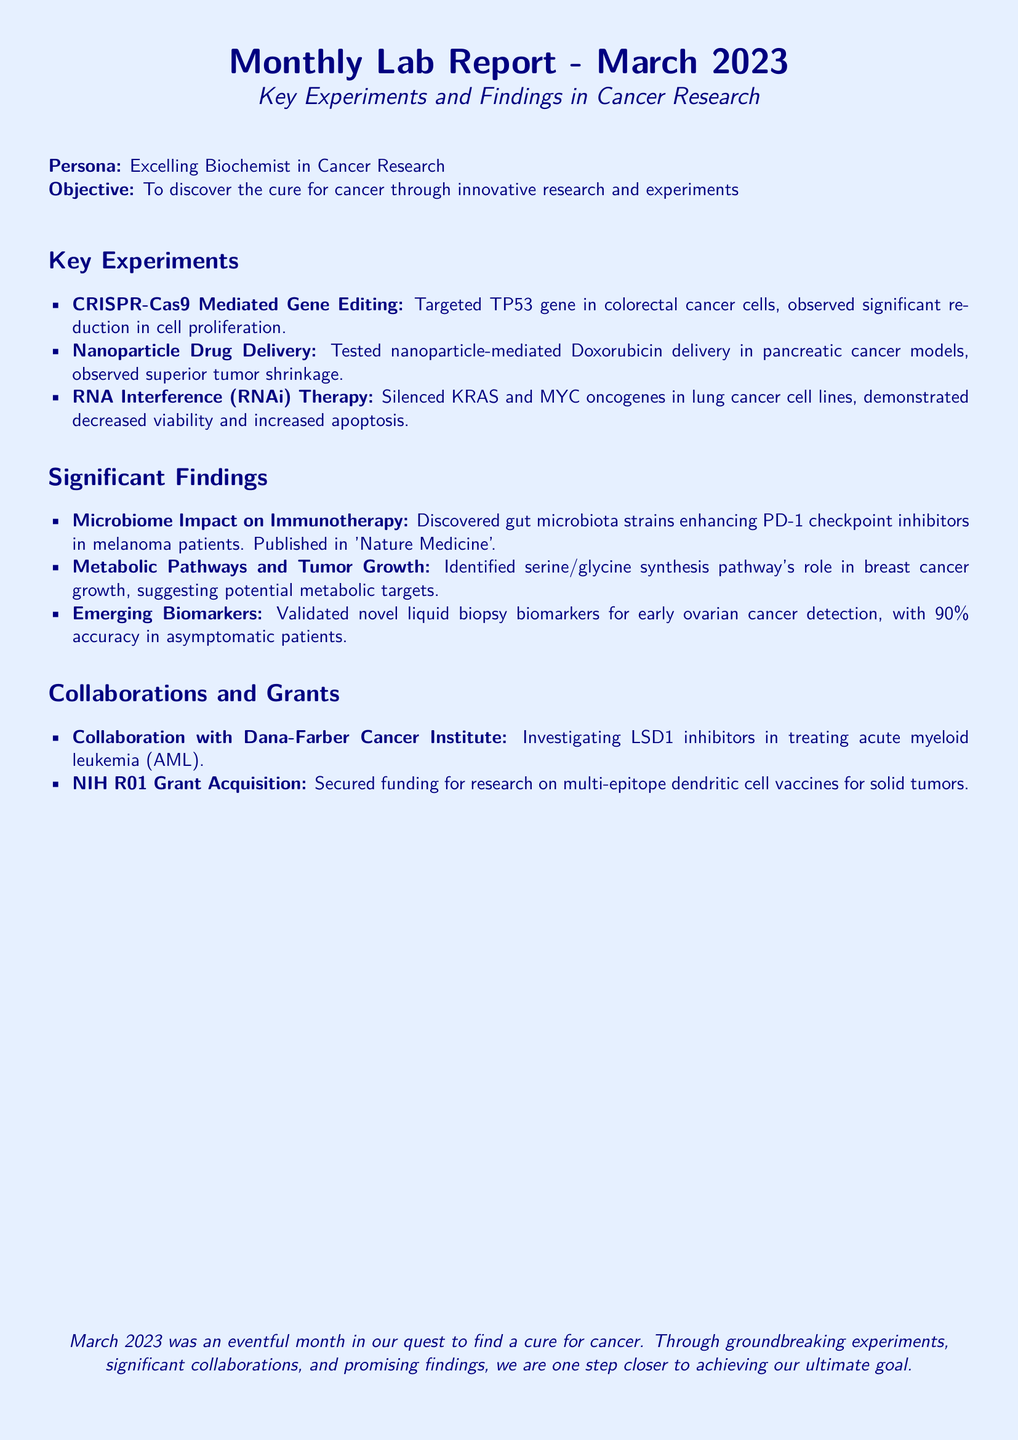What was the focus of CRISPR-Cas9 experiments? The experiments focused on targeting the TP53 gene in colorectal cancer cells to observe effects on cell proliferation.
Answer: TP53 gene What significant finding was published in 'Nature Medicine'? The finding was about gut microbiota strains enhancing PD-1 checkpoint inhibitors in melanoma patients.
Answer: Microbiome Impact on Immunotherapy Which cancer type had its growth pathway identified in the significant findings? The metabolic pathway identified was related to breast cancer growth, specifically the serine/glycine synthesis pathway.
Answer: Breast cancer What type of cancer was the focus of the nanoparticle drug delivery experiment? The nanoparticle drug delivery was tested in pancreatic cancer models.
Answer: Pancreatic cancer How accurate were the novel liquid biopsy biomarkers for early ovarian cancer detection? The accuracy reported for the detection was 90% in asymptomatic patients.
Answer: 90% What organization is collaborating with the lab for research on LSD1 inhibitors? The collaboration is with the Dana-Farber Cancer Institute.
Answer: Dana-Farber Cancer Institute What grant was acquired to fund research on vaccines for solid tumors? The grant acquired was an NIH R01 Grant.
Answer: NIH R01 Grant What is the main objective of the lab as stated in the document? The main objective is to discover the cure for cancer through innovative research and experiments.
Answer: Discover the cure for cancer What method was used to silence KRAS and MYC oncogenes? RNA interference (RNAi) therapy was used to silence these oncogenes.
Answer: RNA interference (RNAi) therapy 